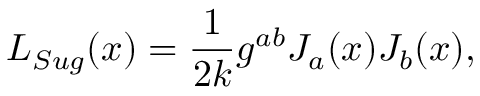<formula> <loc_0><loc_0><loc_500><loc_500>L _ { S u g } ( x ) = \frac { 1 } { 2 k } g ^ { a b } J _ { a } ( x ) J _ { b } ( x ) ,</formula> 